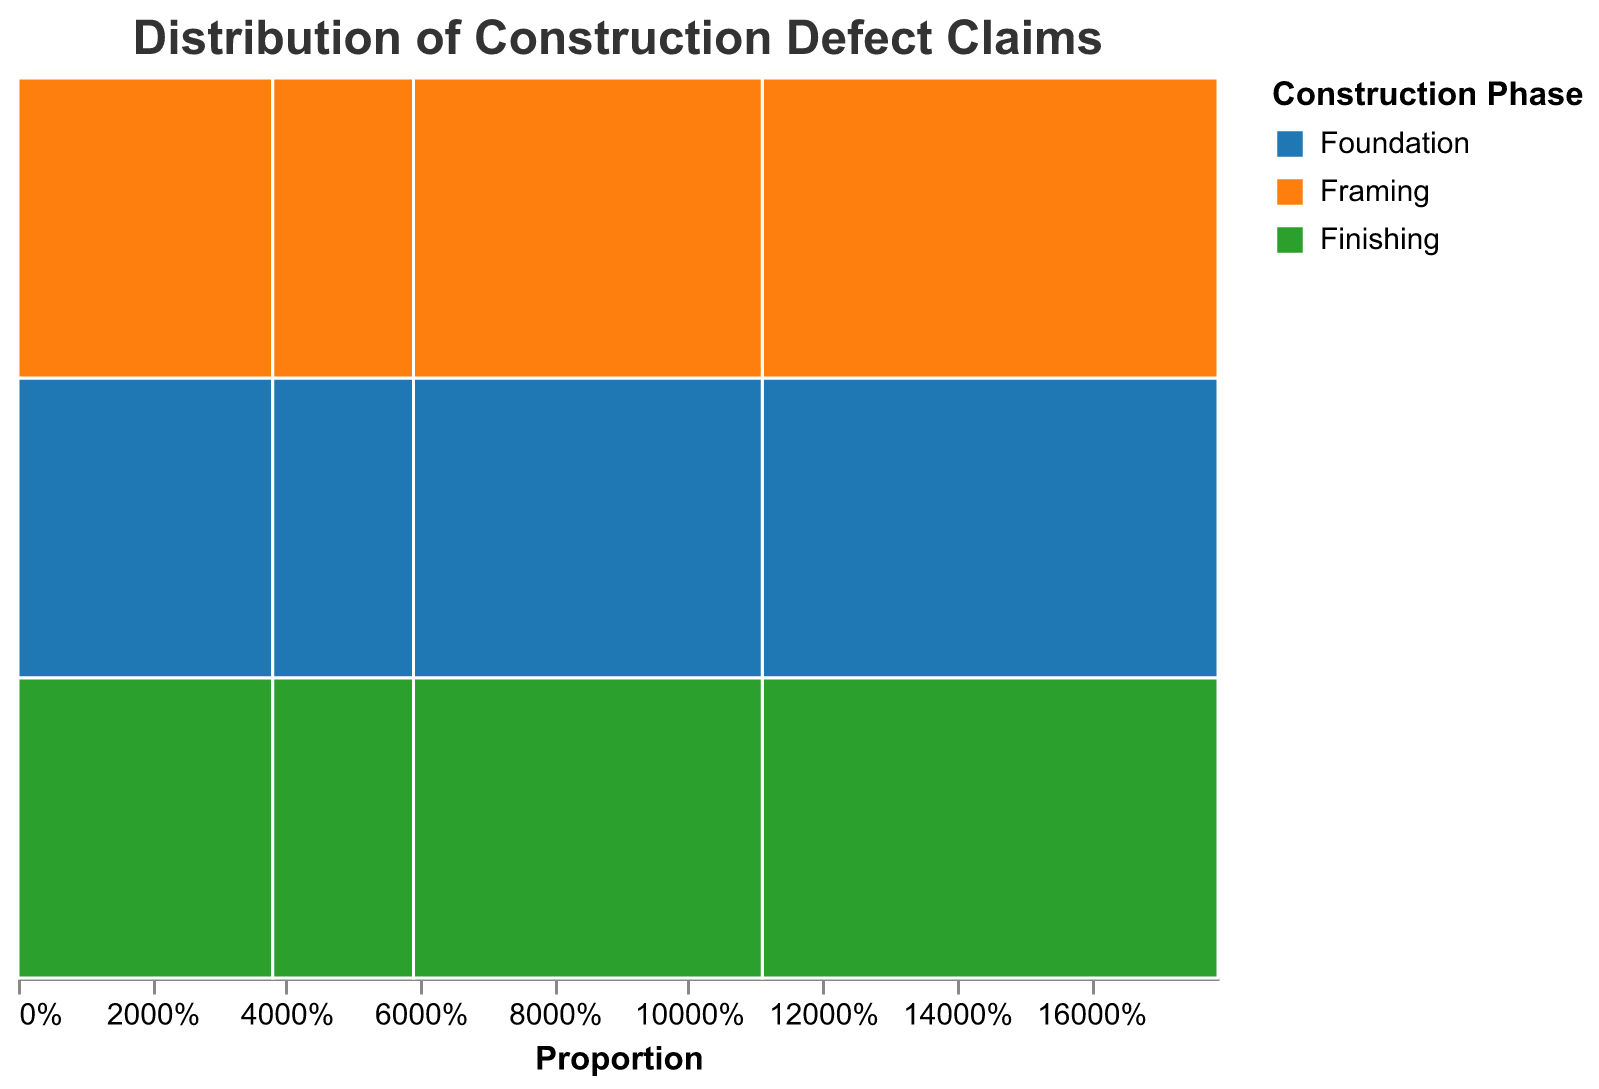What is the title of the figure? The title of the figure is shown at the top center of the chart and is typically larger in font size than other text.
Answer: Distribution of Construction Defect Claims How many claim categories (i.e., Construction Phases) are there? The legend on the right side of the plot shows three different colors, each representing a construction phase category.
Answer: Three What color represents the "Framing" construction phase? The legend indicates that "Framing" is represented by an orange color.
Answer: Orange Which building type has the highest number of claims during the "Foundation" phase? By looking at the color segment corresponding to "Foundation" (blue) across all building types, "Residential" has the widest blue segment, indicating the highest count.
Answer: Residential How many claims are there in total for the "Commercial" building type? By summing the claim counts for the "Commercial" building type across all phases: 8 (Foundation) + 12 (Framing) + 18 (Finishing) = 38.
Answer: 38 What is the construction phase with the highest number of claims for the "Mixed-Use" building type? By examining the height of the colored segments for "Mixed-Use," the green segment (Finishing) is the tallest, indicating the phase with the highest number of claims.
Answer: Finishing How does the number of claims in the "Framing" phase for "Residential" buildings compare to that for "Commercial" buildings? The width of the orange segment for "Residential" in the "Framing" phase is wider than that for "Commercial," and the tooltip data confirms 22 claims for "Residential" compared to 12 for "Commercial."
Answer: Residential has more claims Which construction phase has the least number of claims for "Industrial" buildings? The height of the colored segments for "Industrial" shows that the green segment (Finishing) is the smallest.
Answer: Finishing What is the total number of claims for "Residential" buildings? By summing the claim counts for the "Residential" building type across all phases: 15 (Foundation) + 22 (Framing) + 31 (Finishing) = 68.
Answer: 68 If you were to order the construction phases by the number of claims for "Mixed-Use," what would the order be? By looking at the height of the segments for "Mixed-Use": Foundation (blue) is smallest, then Framing (orange), and Finishing (green) is the largest.
Answer: Foundation, Framing, Finishing 